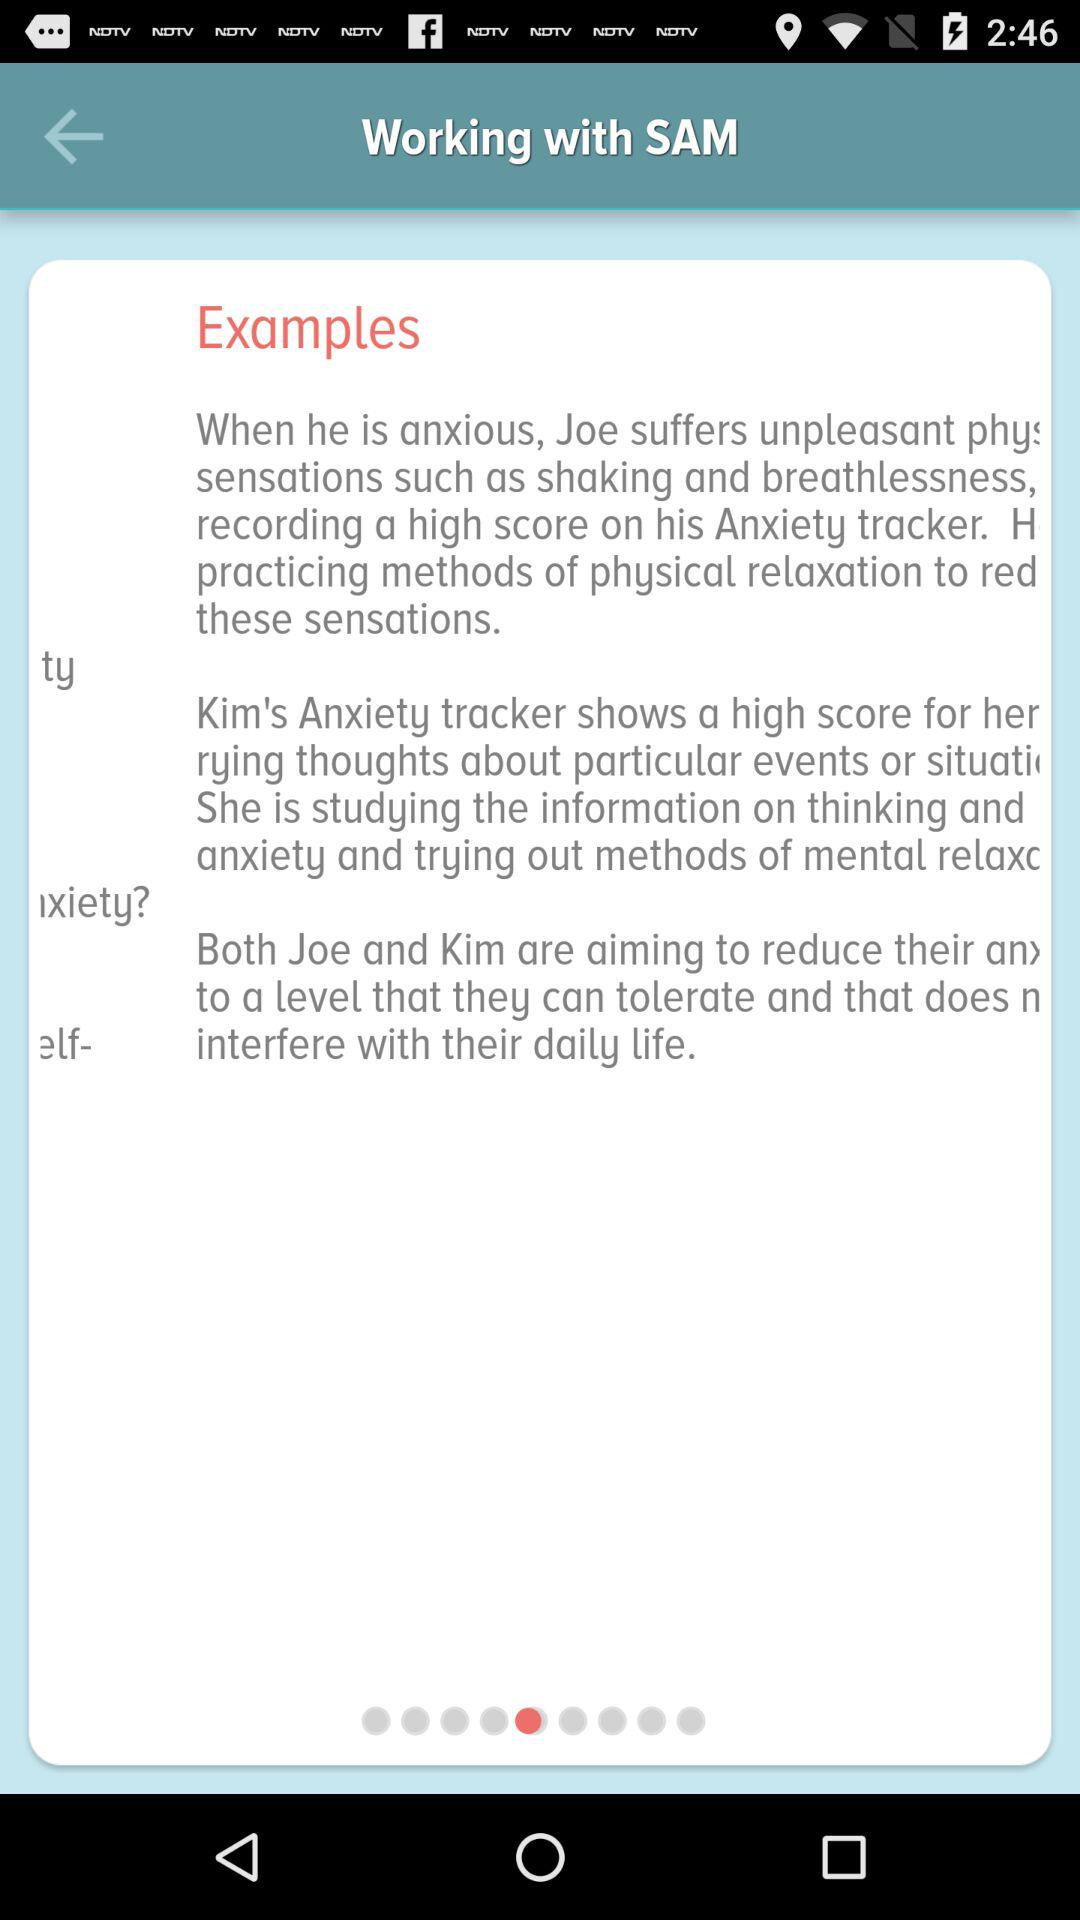How many people are trying to reduce their anxiety?
Answer the question using a single word or phrase. 2 